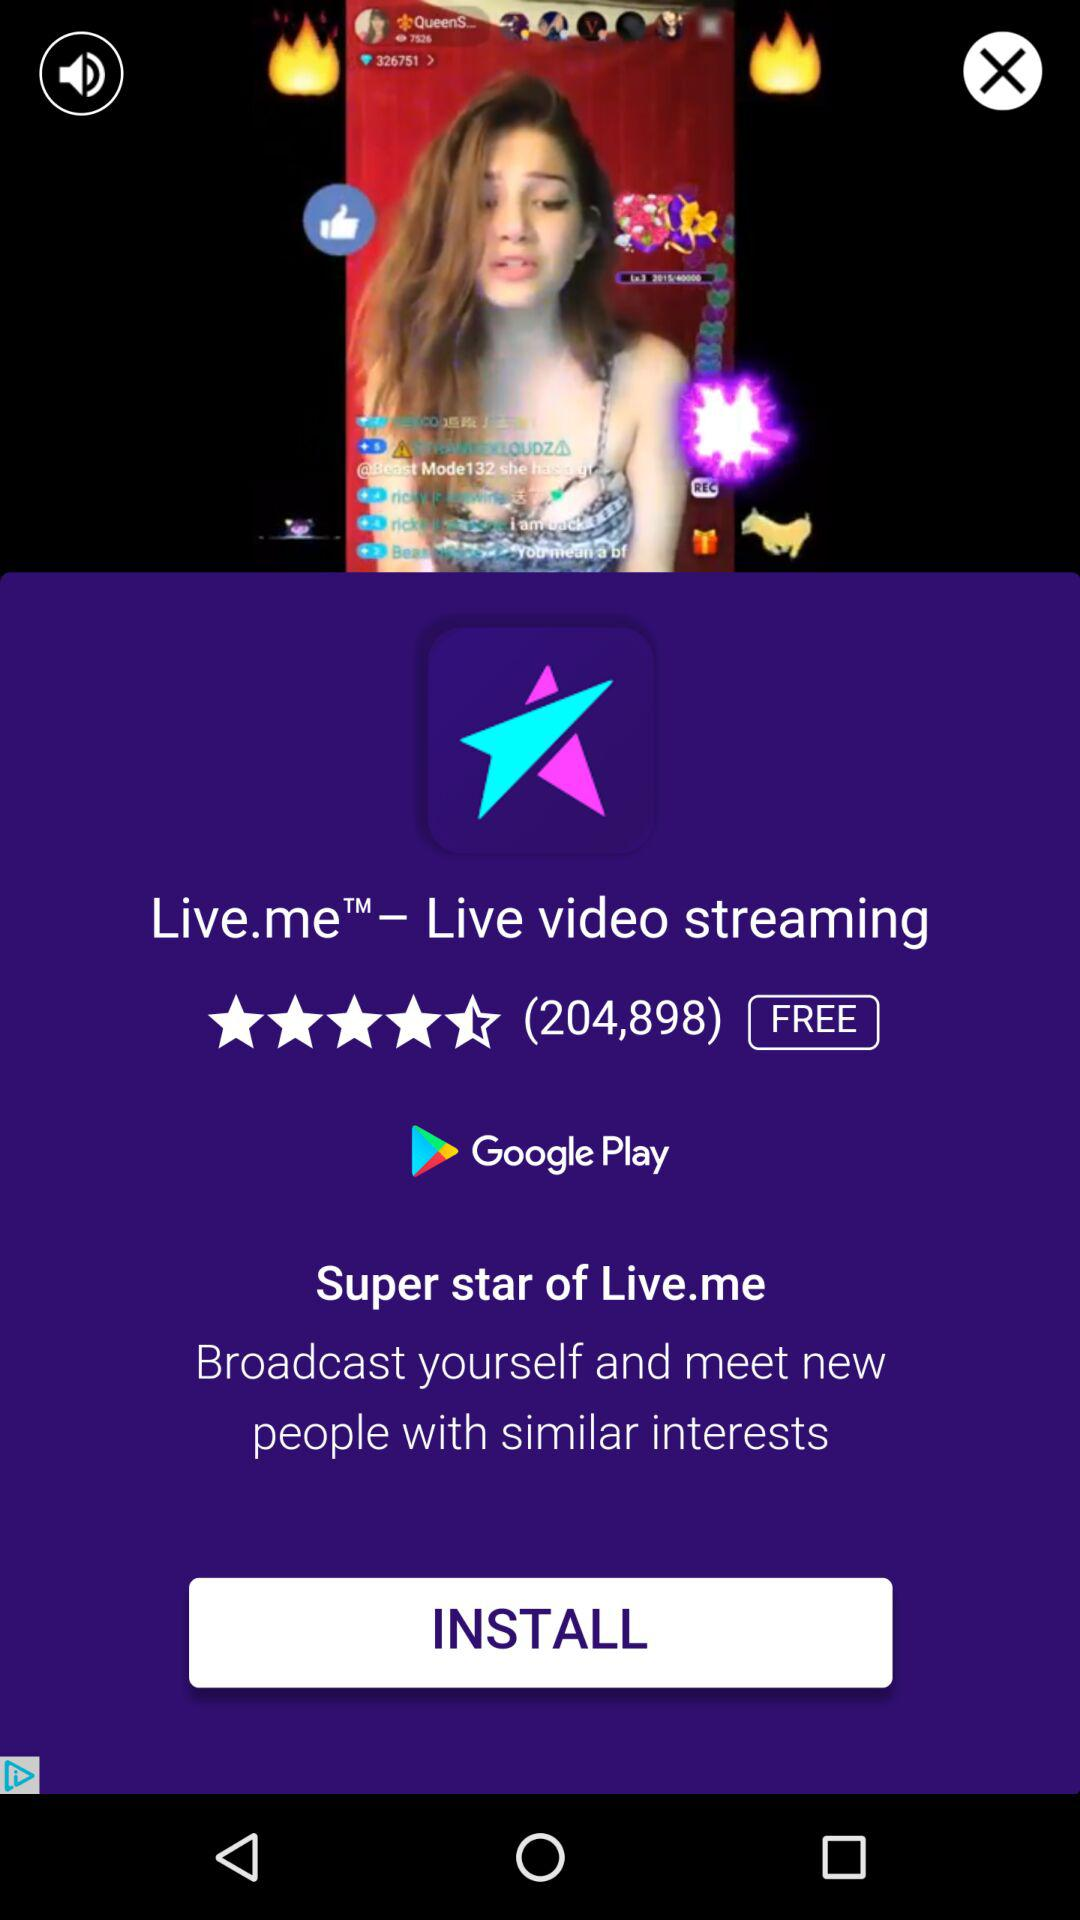How many people have rated the app?
Answer the question using a single word or phrase. 204,898 